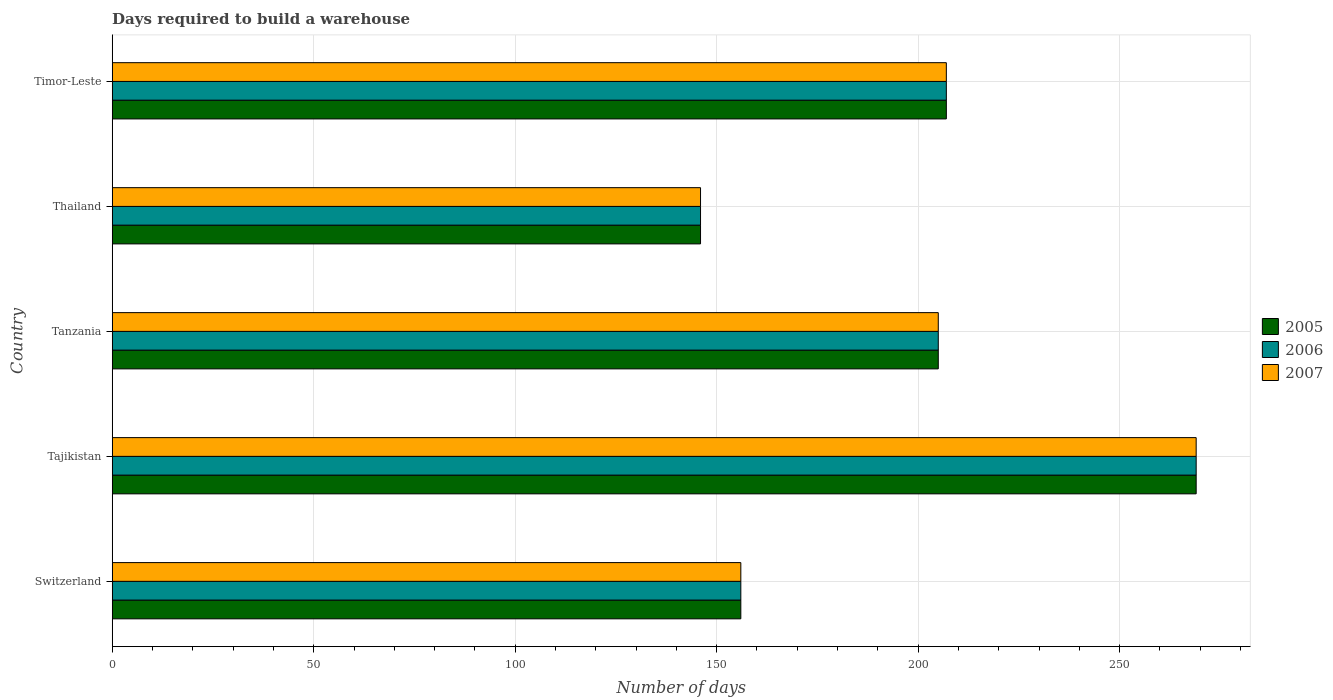How many different coloured bars are there?
Offer a very short reply. 3. How many groups of bars are there?
Offer a terse response. 5. How many bars are there on the 4th tick from the top?
Ensure brevity in your answer.  3. What is the label of the 5th group of bars from the top?
Your response must be concise. Switzerland. In how many cases, is the number of bars for a given country not equal to the number of legend labels?
Keep it short and to the point. 0. What is the days required to build a warehouse in in 2007 in Thailand?
Your response must be concise. 146. Across all countries, what is the maximum days required to build a warehouse in in 2006?
Offer a terse response. 269. Across all countries, what is the minimum days required to build a warehouse in in 2006?
Make the answer very short. 146. In which country was the days required to build a warehouse in in 2005 maximum?
Offer a terse response. Tajikistan. In which country was the days required to build a warehouse in in 2006 minimum?
Ensure brevity in your answer.  Thailand. What is the total days required to build a warehouse in in 2005 in the graph?
Your answer should be compact. 983. What is the difference between the days required to build a warehouse in in 2006 in Switzerland and that in Timor-Leste?
Give a very brief answer. -51. What is the difference between the days required to build a warehouse in in 2006 in Tanzania and the days required to build a warehouse in in 2007 in Tajikistan?
Offer a terse response. -64. What is the average days required to build a warehouse in in 2006 per country?
Ensure brevity in your answer.  196.6. What is the ratio of the days required to build a warehouse in in 2007 in Switzerland to that in Tanzania?
Keep it short and to the point. 0.76. What is the difference between the highest and the lowest days required to build a warehouse in in 2006?
Make the answer very short. 123. What does the 1st bar from the bottom in Switzerland represents?
Keep it short and to the point. 2005. Is it the case that in every country, the sum of the days required to build a warehouse in in 2007 and days required to build a warehouse in in 2005 is greater than the days required to build a warehouse in in 2006?
Provide a succinct answer. Yes. How many bars are there?
Provide a short and direct response. 15. What is the difference between two consecutive major ticks on the X-axis?
Your answer should be compact. 50. Does the graph contain any zero values?
Your response must be concise. No. Does the graph contain grids?
Provide a short and direct response. Yes. Where does the legend appear in the graph?
Ensure brevity in your answer.  Center right. How many legend labels are there?
Offer a terse response. 3. What is the title of the graph?
Provide a succinct answer. Days required to build a warehouse. Does "1972" appear as one of the legend labels in the graph?
Give a very brief answer. No. What is the label or title of the X-axis?
Your response must be concise. Number of days. What is the label or title of the Y-axis?
Provide a succinct answer. Country. What is the Number of days in 2005 in Switzerland?
Your response must be concise. 156. What is the Number of days in 2006 in Switzerland?
Make the answer very short. 156. What is the Number of days of 2007 in Switzerland?
Your response must be concise. 156. What is the Number of days of 2005 in Tajikistan?
Give a very brief answer. 269. What is the Number of days of 2006 in Tajikistan?
Keep it short and to the point. 269. What is the Number of days in 2007 in Tajikistan?
Offer a terse response. 269. What is the Number of days in 2005 in Tanzania?
Give a very brief answer. 205. What is the Number of days in 2006 in Tanzania?
Your response must be concise. 205. What is the Number of days in 2007 in Tanzania?
Your answer should be compact. 205. What is the Number of days in 2005 in Thailand?
Make the answer very short. 146. What is the Number of days of 2006 in Thailand?
Your answer should be compact. 146. What is the Number of days of 2007 in Thailand?
Provide a short and direct response. 146. What is the Number of days of 2005 in Timor-Leste?
Keep it short and to the point. 207. What is the Number of days in 2006 in Timor-Leste?
Make the answer very short. 207. What is the Number of days of 2007 in Timor-Leste?
Give a very brief answer. 207. Across all countries, what is the maximum Number of days in 2005?
Offer a terse response. 269. Across all countries, what is the maximum Number of days of 2006?
Offer a terse response. 269. Across all countries, what is the maximum Number of days of 2007?
Your response must be concise. 269. Across all countries, what is the minimum Number of days of 2005?
Your response must be concise. 146. Across all countries, what is the minimum Number of days of 2006?
Your answer should be compact. 146. Across all countries, what is the minimum Number of days of 2007?
Offer a terse response. 146. What is the total Number of days in 2005 in the graph?
Give a very brief answer. 983. What is the total Number of days in 2006 in the graph?
Your response must be concise. 983. What is the total Number of days of 2007 in the graph?
Your answer should be very brief. 983. What is the difference between the Number of days in 2005 in Switzerland and that in Tajikistan?
Give a very brief answer. -113. What is the difference between the Number of days of 2006 in Switzerland and that in Tajikistan?
Your answer should be very brief. -113. What is the difference between the Number of days of 2007 in Switzerland and that in Tajikistan?
Ensure brevity in your answer.  -113. What is the difference between the Number of days in 2005 in Switzerland and that in Tanzania?
Make the answer very short. -49. What is the difference between the Number of days of 2006 in Switzerland and that in Tanzania?
Your response must be concise. -49. What is the difference between the Number of days in 2007 in Switzerland and that in Tanzania?
Provide a short and direct response. -49. What is the difference between the Number of days of 2005 in Switzerland and that in Thailand?
Provide a succinct answer. 10. What is the difference between the Number of days of 2006 in Switzerland and that in Thailand?
Provide a short and direct response. 10. What is the difference between the Number of days of 2005 in Switzerland and that in Timor-Leste?
Provide a succinct answer. -51. What is the difference between the Number of days in 2006 in Switzerland and that in Timor-Leste?
Your answer should be compact. -51. What is the difference between the Number of days of 2007 in Switzerland and that in Timor-Leste?
Your answer should be compact. -51. What is the difference between the Number of days of 2005 in Tajikistan and that in Tanzania?
Provide a succinct answer. 64. What is the difference between the Number of days of 2007 in Tajikistan and that in Tanzania?
Your response must be concise. 64. What is the difference between the Number of days of 2005 in Tajikistan and that in Thailand?
Your answer should be very brief. 123. What is the difference between the Number of days of 2006 in Tajikistan and that in Thailand?
Offer a very short reply. 123. What is the difference between the Number of days in 2007 in Tajikistan and that in Thailand?
Your response must be concise. 123. What is the difference between the Number of days of 2005 in Tajikistan and that in Timor-Leste?
Offer a terse response. 62. What is the difference between the Number of days of 2006 in Tajikistan and that in Timor-Leste?
Offer a very short reply. 62. What is the difference between the Number of days in 2007 in Tajikistan and that in Timor-Leste?
Provide a succinct answer. 62. What is the difference between the Number of days of 2007 in Tanzania and that in Thailand?
Your answer should be very brief. 59. What is the difference between the Number of days of 2007 in Tanzania and that in Timor-Leste?
Keep it short and to the point. -2. What is the difference between the Number of days of 2005 in Thailand and that in Timor-Leste?
Your answer should be compact. -61. What is the difference between the Number of days in 2006 in Thailand and that in Timor-Leste?
Your answer should be very brief. -61. What is the difference between the Number of days of 2007 in Thailand and that in Timor-Leste?
Ensure brevity in your answer.  -61. What is the difference between the Number of days of 2005 in Switzerland and the Number of days of 2006 in Tajikistan?
Keep it short and to the point. -113. What is the difference between the Number of days in 2005 in Switzerland and the Number of days in 2007 in Tajikistan?
Give a very brief answer. -113. What is the difference between the Number of days in 2006 in Switzerland and the Number of days in 2007 in Tajikistan?
Your response must be concise. -113. What is the difference between the Number of days of 2005 in Switzerland and the Number of days of 2006 in Tanzania?
Offer a very short reply. -49. What is the difference between the Number of days of 2005 in Switzerland and the Number of days of 2007 in Tanzania?
Provide a short and direct response. -49. What is the difference between the Number of days in 2006 in Switzerland and the Number of days in 2007 in Tanzania?
Provide a succinct answer. -49. What is the difference between the Number of days of 2005 in Switzerland and the Number of days of 2006 in Thailand?
Provide a short and direct response. 10. What is the difference between the Number of days in 2005 in Switzerland and the Number of days in 2006 in Timor-Leste?
Provide a succinct answer. -51. What is the difference between the Number of days in 2005 in Switzerland and the Number of days in 2007 in Timor-Leste?
Your response must be concise. -51. What is the difference between the Number of days in 2006 in Switzerland and the Number of days in 2007 in Timor-Leste?
Provide a short and direct response. -51. What is the difference between the Number of days of 2005 in Tajikistan and the Number of days of 2007 in Tanzania?
Your response must be concise. 64. What is the difference between the Number of days in 2005 in Tajikistan and the Number of days in 2006 in Thailand?
Your answer should be very brief. 123. What is the difference between the Number of days of 2005 in Tajikistan and the Number of days of 2007 in Thailand?
Make the answer very short. 123. What is the difference between the Number of days of 2006 in Tajikistan and the Number of days of 2007 in Thailand?
Your response must be concise. 123. What is the difference between the Number of days in 2005 in Tajikistan and the Number of days in 2006 in Timor-Leste?
Make the answer very short. 62. What is the difference between the Number of days of 2006 in Tajikistan and the Number of days of 2007 in Timor-Leste?
Ensure brevity in your answer.  62. What is the difference between the Number of days in 2005 in Tanzania and the Number of days in 2006 in Timor-Leste?
Ensure brevity in your answer.  -2. What is the difference between the Number of days of 2005 in Tanzania and the Number of days of 2007 in Timor-Leste?
Make the answer very short. -2. What is the difference between the Number of days of 2005 in Thailand and the Number of days of 2006 in Timor-Leste?
Keep it short and to the point. -61. What is the difference between the Number of days in 2005 in Thailand and the Number of days in 2007 in Timor-Leste?
Make the answer very short. -61. What is the difference between the Number of days in 2006 in Thailand and the Number of days in 2007 in Timor-Leste?
Give a very brief answer. -61. What is the average Number of days in 2005 per country?
Offer a terse response. 196.6. What is the average Number of days in 2006 per country?
Give a very brief answer. 196.6. What is the average Number of days of 2007 per country?
Provide a succinct answer. 196.6. What is the difference between the Number of days in 2006 and Number of days in 2007 in Switzerland?
Offer a very short reply. 0. What is the difference between the Number of days of 2005 and Number of days of 2007 in Tajikistan?
Provide a succinct answer. 0. What is the difference between the Number of days in 2005 and Number of days in 2006 in Tanzania?
Offer a terse response. 0. What is the difference between the Number of days in 2005 and Number of days in 2007 in Tanzania?
Make the answer very short. 0. What is the difference between the Number of days of 2005 and Number of days of 2007 in Thailand?
Ensure brevity in your answer.  0. What is the difference between the Number of days of 2006 and Number of days of 2007 in Thailand?
Make the answer very short. 0. What is the difference between the Number of days of 2005 and Number of days of 2007 in Timor-Leste?
Your response must be concise. 0. What is the ratio of the Number of days of 2005 in Switzerland to that in Tajikistan?
Offer a terse response. 0.58. What is the ratio of the Number of days of 2006 in Switzerland to that in Tajikistan?
Your response must be concise. 0.58. What is the ratio of the Number of days of 2007 in Switzerland to that in Tajikistan?
Your answer should be very brief. 0.58. What is the ratio of the Number of days of 2005 in Switzerland to that in Tanzania?
Give a very brief answer. 0.76. What is the ratio of the Number of days of 2006 in Switzerland to that in Tanzania?
Make the answer very short. 0.76. What is the ratio of the Number of days in 2007 in Switzerland to that in Tanzania?
Give a very brief answer. 0.76. What is the ratio of the Number of days of 2005 in Switzerland to that in Thailand?
Provide a short and direct response. 1.07. What is the ratio of the Number of days in 2006 in Switzerland to that in Thailand?
Offer a terse response. 1.07. What is the ratio of the Number of days of 2007 in Switzerland to that in Thailand?
Your response must be concise. 1.07. What is the ratio of the Number of days of 2005 in Switzerland to that in Timor-Leste?
Keep it short and to the point. 0.75. What is the ratio of the Number of days in 2006 in Switzerland to that in Timor-Leste?
Your answer should be compact. 0.75. What is the ratio of the Number of days in 2007 in Switzerland to that in Timor-Leste?
Ensure brevity in your answer.  0.75. What is the ratio of the Number of days of 2005 in Tajikistan to that in Tanzania?
Give a very brief answer. 1.31. What is the ratio of the Number of days in 2006 in Tajikistan to that in Tanzania?
Provide a succinct answer. 1.31. What is the ratio of the Number of days in 2007 in Tajikistan to that in Tanzania?
Your response must be concise. 1.31. What is the ratio of the Number of days of 2005 in Tajikistan to that in Thailand?
Your answer should be compact. 1.84. What is the ratio of the Number of days of 2006 in Tajikistan to that in Thailand?
Offer a very short reply. 1.84. What is the ratio of the Number of days in 2007 in Tajikistan to that in Thailand?
Your response must be concise. 1.84. What is the ratio of the Number of days in 2005 in Tajikistan to that in Timor-Leste?
Offer a very short reply. 1.3. What is the ratio of the Number of days in 2006 in Tajikistan to that in Timor-Leste?
Offer a terse response. 1.3. What is the ratio of the Number of days in 2007 in Tajikistan to that in Timor-Leste?
Keep it short and to the point. 1.3. What is the ratio of the Number of days of 2005 in Tanzania to that in Thailand?
Offer a very short reply. 1.4. What is the ratio of the Number of days of 2006 in Tanzania to that in Thailand?
Offer a very short reply. 1.4. What is the ratio of the Number of days in 2007 in Tanzania to that in Thailand?
Your answer should be compact. 1.4. What is the ratio of the Number of days of 2005 in Tanzania to that in Timor-Leste?
Give a very brief answer. 0.99. What is the ratio of the Number of days of 2006 in Tanzania to that in Timor-Leste?
Your answer should be compact. 0.99. What is the ratio of the Number of days in 2007 in Tanzania to that in Timor-Leste?
Ensure brevity in your answer.  0.99. What is the ratio of the Number of days in 2005 in Thailand to that in Timor-Leste?
Provide a succinct answer. 0.71. What is the ratio of the Number of days of 2006 in Thailand to that in Timor-Leste?
Provide a succinct answer. 0.71. What is the ratio of the Number of days of 2007 in Thailand to that in Timor-Leste?
Ensure brevity in your answer.  0.71. What is the difference between the highest and the second highest Number of days of 2006?
Offer a terse response. 62. What is the difference between the highest and the lowest Number of days in 2005?
Your answer should be very brief. 123. What is the difference between the highest and the lowest Number of days in 2006?
Provide a short and direct response. 123. What is the difference between the highest and the lowest Number of days of 2007?
Your answer should be very brief. 123. 